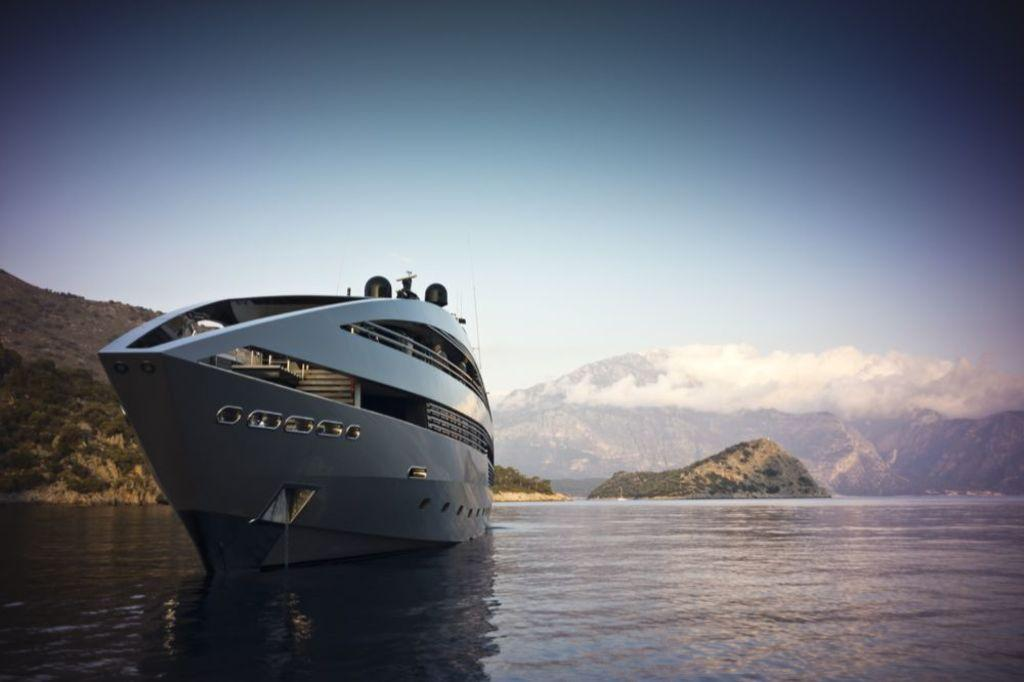What is the main subject of the image? The main subject of the image is a ship. Where is the ship located? The ship is on the water. What type of natural features can be seen in the image? There are trees and mountains visible in the image. What is visible in the background of the image? The sky is visible in the background of the image. Can you tell me how many ducks are swimming near the ship in the image? There are no ducks present in the image; it features a ship on the water with trees and mountains in the background. 